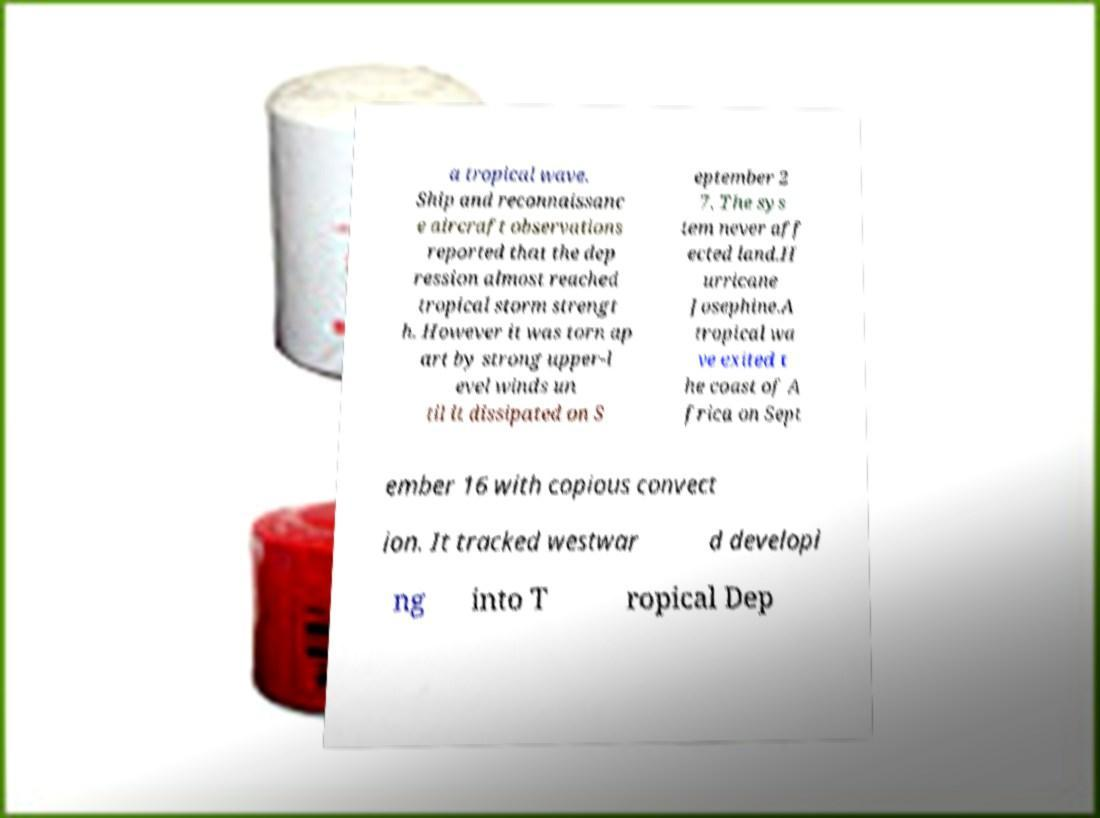Please read and relay the text visible in this image. What does it say? a tropical wave. Ship and reconnaissanc e aircraft observations reported that the dep ression almost reached tropical storm strengt h. However it was torn ap art by strong upper-l evel winds un til it dissipated on S eptember 2 7. The sys tem never aff ected land.H urricane Josephine.A tropical wa ve exited t he coast of A frica on Sept ember 16 with copious convect ion. It tracked westwar d developi ng into T ropical Dep 